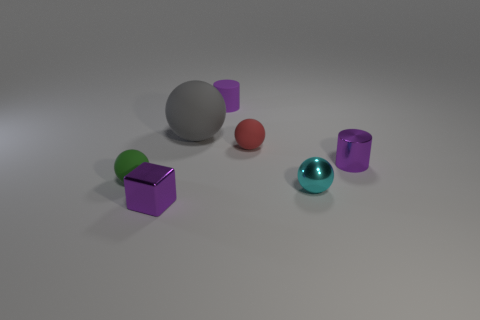Is there anything else that is the same size as the gray matte sphere?
Provide a succinct answer. No. Does the purple thing that is to the left of the small purple rubber cylinder have the same shape as the tiny red matte object?
Provide a short and direct response. No. What size is the purple cylinder that is in front of the cylinder that is behind the tiny thing on the right side of the tiny cyan metallic sphere?
Your response must be concise. Small. What size is the metal cube that is the same color as the metallic cylinder?
Offer a very short reply. Small. What number of things are either green things or large green cylinders?
Ensure brevity in your answer.  1. The tiny object that is both in front of the small green ball and behind the purple cube has what shape?
Provide a succinct answer. Sphere. Does the large object have the same shape as the purple thing in front of the tiny green rubber ball?
Your answer should be very brief. No. There is a purple metal cylinder; are there any metallic cylinders behind it?
Provide a succinct answer. No. There is another small cylinder that is the same color as the small matte cylinder; what is it made of?
Your answer should be very brief. Metal. How many cylinders are blue rubber things or cyan things?
Your response must be concise. 0. 